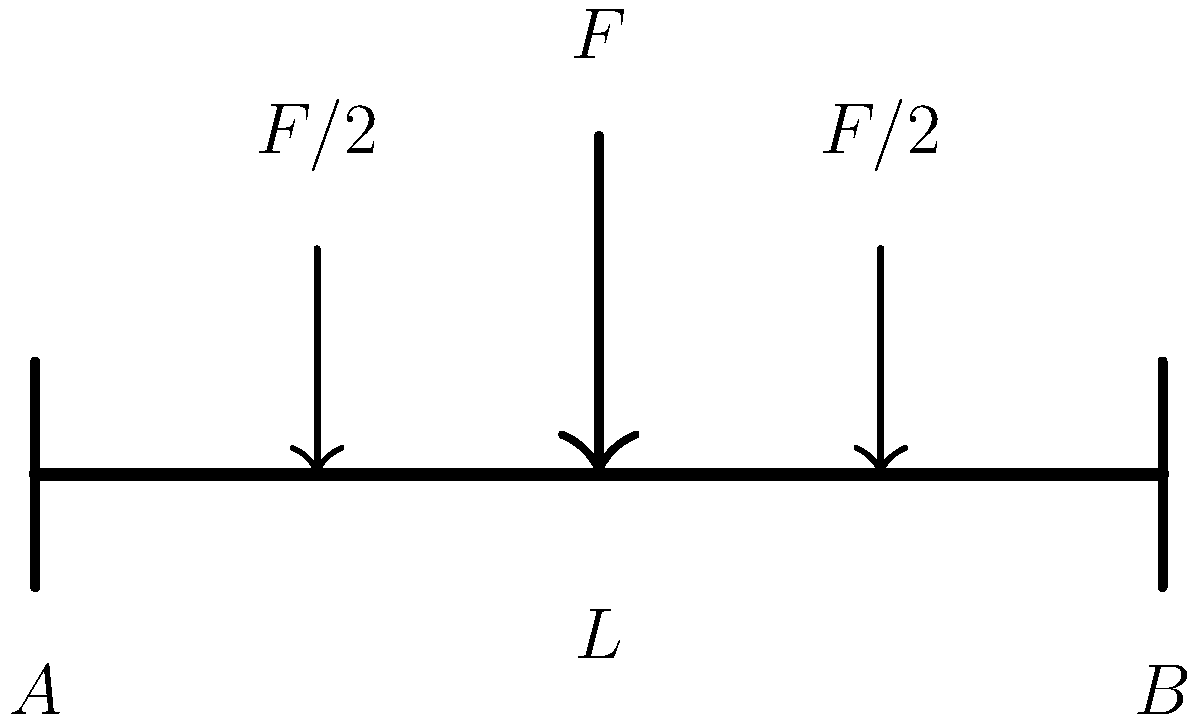In a traditional Japanese wooden bridge structure, a central load $F$ is applied at the midpoint, which is then distributed equally to two points at quarter-spans. If the bridge span is $L$, what is the reaction force at support $A$ in terms of $F$? To solve this problem, we'll follow these steps:

1. Identify the loading conditions:
   - Central load $F$ at midspan
   - Two distributed loads of $F/2$ at quarter-spans

2. Use the principle of moments to calculate the reaction force at support $A$:
   - Take moments about support $B$

3. Sum of moments about $B$ = 0:
   $R_A \cdot L - (F/2) \cdot (3L/4) - (F/2) \cdot (L/4) - F \cdot (L/2) = 0$

4. Simplify the equation:
   $R_A \cdot L - (3FL/8) - (FL/8) - (FL/2) = 0$
   $R_A \cdot L - (3FL/8) - (FL/8) - (4FL/8) = 0$
   $R_A \cdot L - (8FL/8) = 0$

5. Solve for $R_A$:
   $R_A = (8FL/8L) = F$

Therefore, the reaction force at support $A$ is equal to the total applied load $F$.
Answer: $F$ 